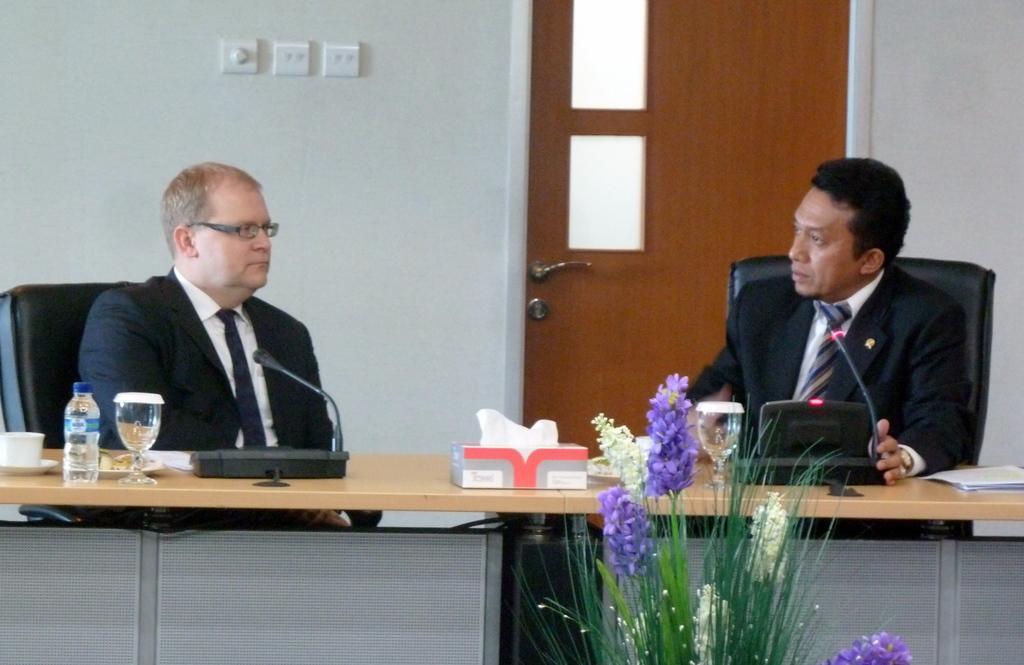Can you describe this image briefly? In this given picture, We can see two people sitting in chairs after that, We can see two miles, a water bottle, two glasses, an artificial tree, few object kept on table behind this two people, We can see a wall, a door which is locked. 